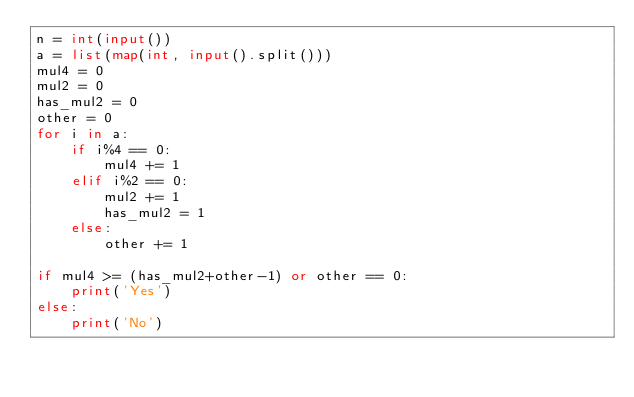<code> <loc_0><loc_0><loc_500><loc_500><_Python_>n = int(input())
a = list(map(int, input().split()))
mul4 = 0
mul2 = 0
has_mul2 = 0
other = 0
for i in a:
    if i%4 == 0:
        mul4 += 1
    elif i%2 == 0:
        mul2 += 1
        has_mul2 = 1
    else:
        other += 1

if mul4 >= (has_mul2+other-1) or other == 0:
    print('Yes')
else:
    print('No')</code> 